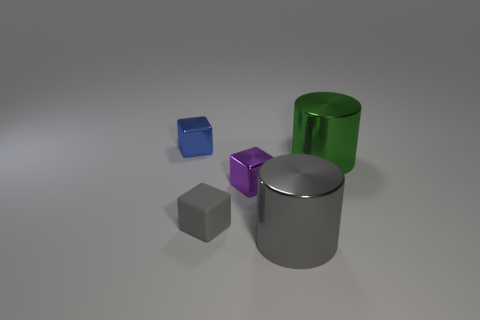Add 2 small blue shiny objects. How many objects exist? 7 Subtract all blocks. How many objects are left? 2 Add 5 large cyan matte cubes. How many large cyan matte cubes exist? 5 Subtract 0 brown balls. How many objects are left? 5 Subtract all big cubes. Subtract all green shiny cylinders. How many objects are left? 4 Add 3 metal cubes. How many metal cubes are left? 5 